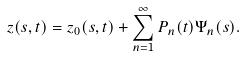Convert formula to latex. <formula><loc_0><loc_0><loc_500><loc_500>z ( s , t ) = z _ { 0 } ( s , t ) + \sum _ { n = 1 } ^ { \infty } P _ { n } ( t ) \Psi _ { n } ( s ) .</formula> 